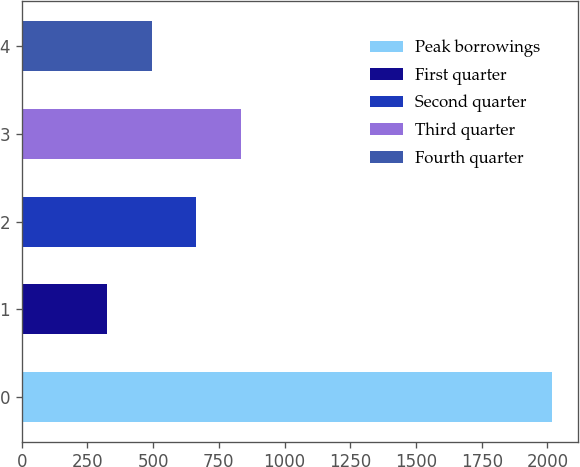Convert chart. <chart><loc_0><loc_0><loc_500><loc_500><bar_chart><fcel>Peak borrowings<fcel>First quarter<fcel>Second quarter<fcel>Third quarter<fcel>Fourth quarter<nl><fcel>2017<fcel>325<fcel>663.4<fcel>832.6<fcel>494.2<nl></chart> 